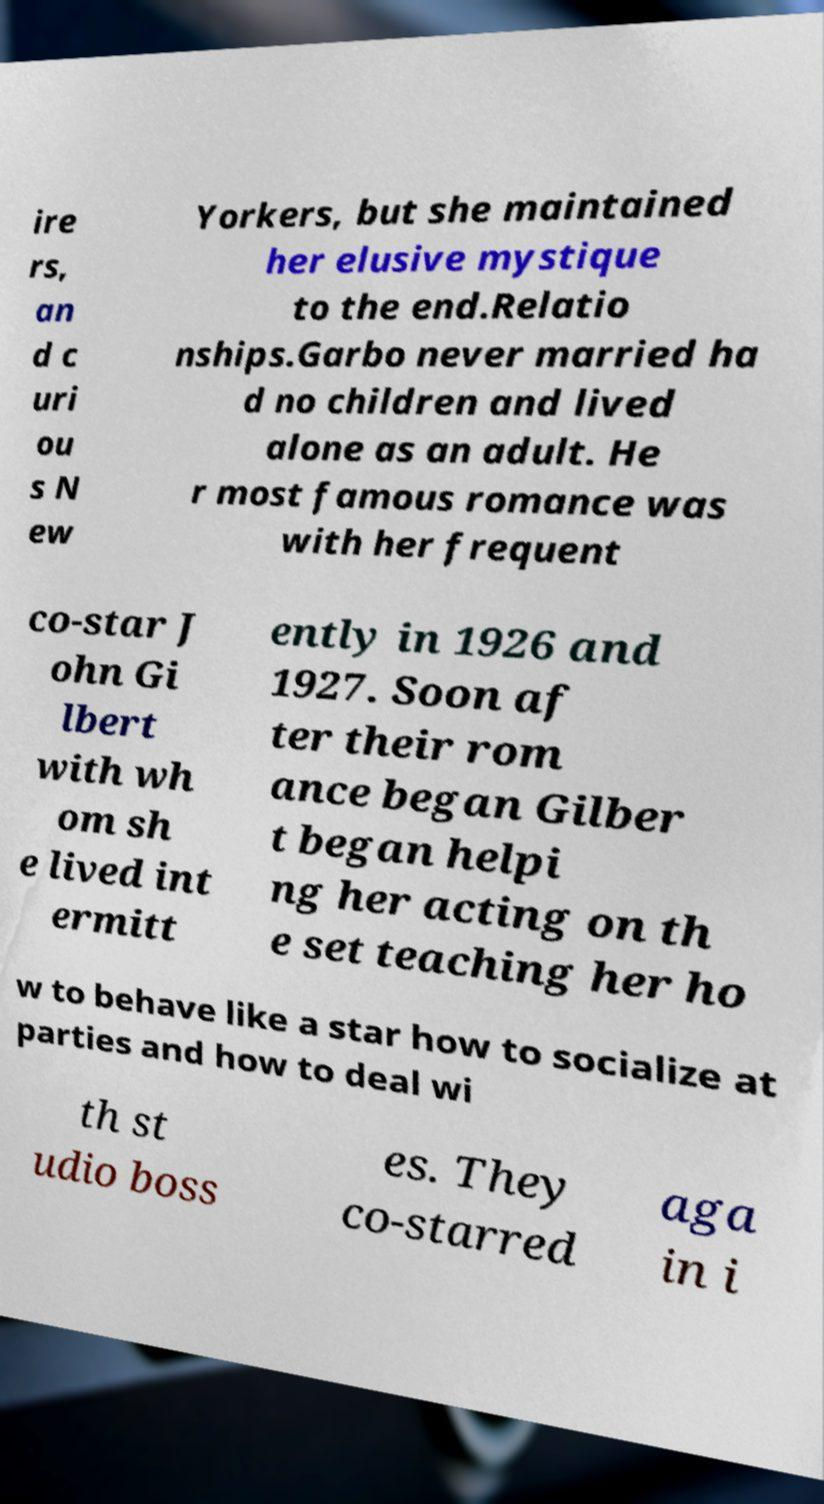Please identify and transcribe the text found in this image. ire rs, an d c uri ou s N ew Yorkers, but she maintained her elusive mystique to the end.Relatio nships.Garbo never married ha d no children and lived alone as an adult. He r most famous romance was with her frequent co-star J ohn Gi lbert with wh om sh e lived int ermitt ently in 1926 and 1927. Soon af ter their rom ance began Gilber t began helpi ng her acting on th e set teaching her ho w to behave like a star how to socialize at parties and how to deal wi th st udio boss es. They co-starred aga in i 